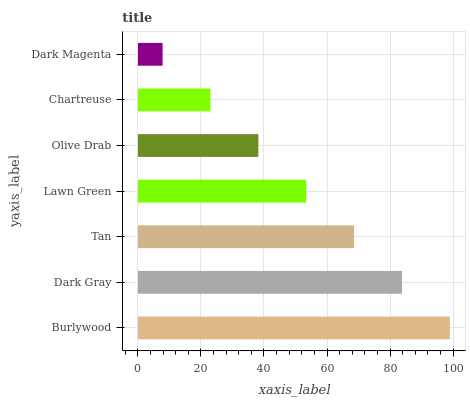Is Dark Magenta the minimum?
Answer yes or no. Yes. Is Burlywood the maximum?
Answer yes or no. Yes. Is Dark Gray the minimum?
Answer yes or no. No. Is Dark Gray the maximum?
Answer yes or no. No. Is Burlywood greater than Dark Gray?
Answer yes or no. Yes. Is Dark Gray less than Burlywood?
Answer yes or no. Yes. Is Dark Gray greater than Burlywood?
Answer yes or no. No. Is Burlywood less than Dark Gray?
Answer yes or no. No. Is Lawn Green the high median?
Answer yes or no. Yes. Is Lawn Green the low median?
Answer yes or no. Yes. Is Tan the high median?
Answer yes or no. No. Is Olive Drab the low median?
Answer yes or no. No. 